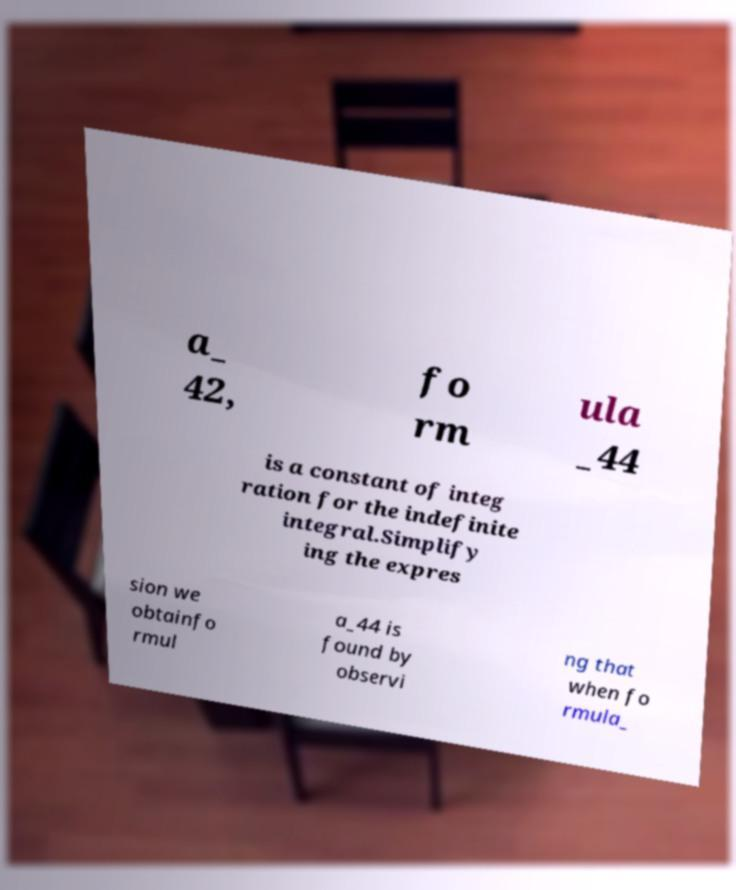Please identify and transcribe the text found in this image. a_ 42, fo rm ula _44 is a constant of integ ration for the indefinite integral.Simplify ing the expres sion we obtainfo rmul a_44 is found by observi ng that when fo rmula_ 